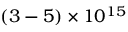<formula> <loc_0><loc_0><loc_500><loc_500>( 3 - 5 ) \times 1 0 ^ { 1 5 }</formula> 